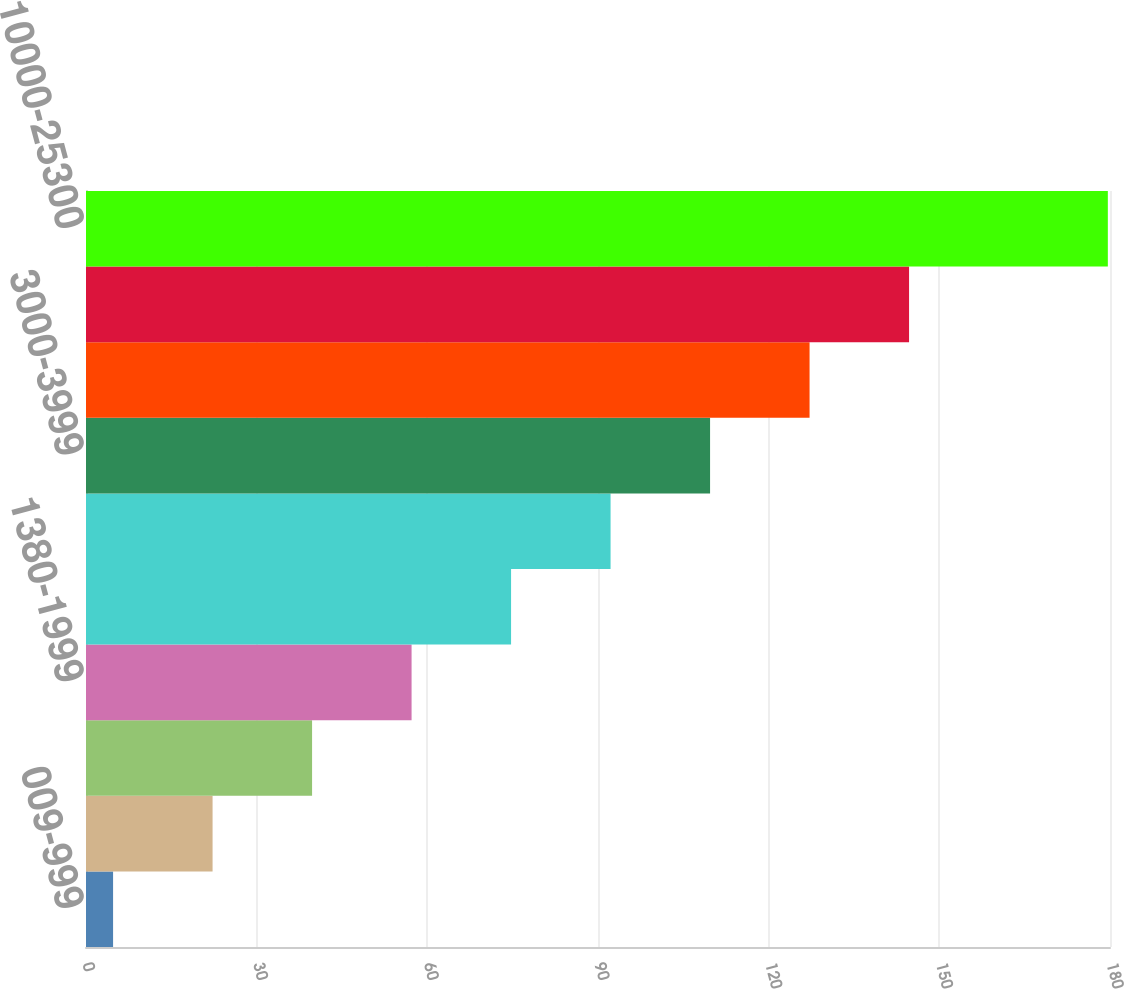<chart> <loc_0><loc_0><loc_500><loc_500><bar_chart><fcel>009-999<fcel>1000-1378<fcel>1379<fcel>1380-1999<fcel>2000-2499<fcel>2500-2999<fcel>3000-3999<fcel>4000-5999<fcel>6000-9999<fcel>10000-25300<nl><fcel>4.76<fcel>22.25<fcel>39.74<fcel>57.23<fcel>74.72<fcel>92.21<fcel>109.7<fcel>127.19<fcel>144.68<fcel>179.62<nl></chart> 